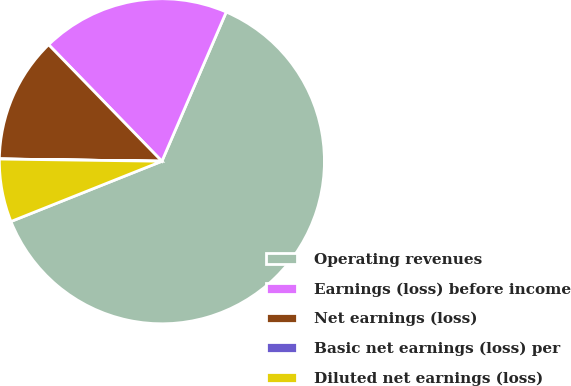Convert chart. <chart><loc_0><loc_0><loc_500><loc_500><pie_chart><fcel>Operating revenues<fcel>Earnings (loss) before income<fcel>Net earnings (loss)<fcel>Basic net earnings (loss) per<fcel>Diluted net earnings (loss)<nl><fcel>62.47%<fcel>18.75%<fcel>12.5%<fcel>0.01%<fcel>6.26%<nl></chart> 